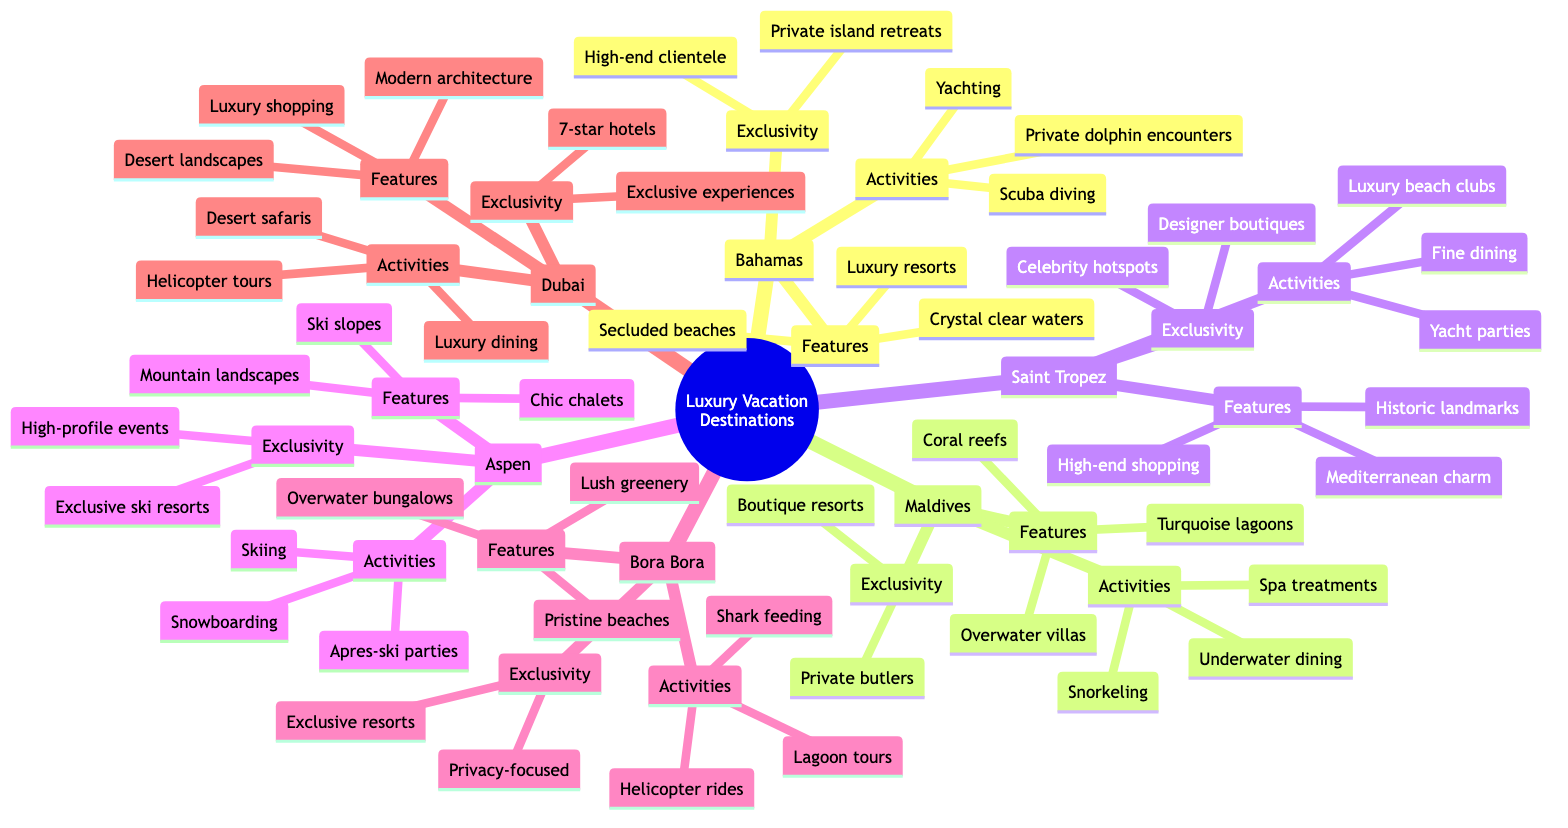What are the features of the Maldives? The diagram indicates that the Maldives has three features listed: "Overwater villas", "Turquoise lagoons", and "Coral reefs".
Answer: Overwater villas, Turquoise lagoons, Coral reefs How many luxury vacation destinations are listed in the diagram? By counting the different locations represented in the diagram, there are six destinations mentioned: Bahamas, Maldives, Saint Tropez, Aspen, Bora Bora, and Dubai.
Answer: 6 What exclusive feature is found in Bora Bora? According to the diagram, one of the exclusive features of Bora Bora is "Exclusive resorts". This information can be directly found in the Exclusive section for Bora Bora.
Answer: Exclusive resorts Which activities can you do in Aspen? The diagram details that three activities can be done in Aspen: "Skiing", "Snowboarding", and "Apres-ski parties". This information summarizes the Activities section for Aspen.
Answer: Skiing, Snowboarding, Apres-ski parties What type of dining experience is available in the Maldives? The diagram specifies that one of the activities in the Maldives is "Underwater dining", indicating a unique dining experience that combines food with an aquatic setting.
Answer: Underwater dining Which destination offers private butlers as part of its exclusivity? By examining the Exclusivity section under Maldives, it is clear that "Private butlers" are mentioned as an exclusive feature, meaning this service is offered in that location only.
Answer: Private butlers How do the features of Saint Tropez compare to those of the Bahamas? The diagram shows that Saint Tropez has "Mediterranean charm", "High-end shopping", and "Historic landmarks", while the Bahamas features "Crystal clear waters", "Secluded beaches", and "Luxury resorts". Comparing both destinations shows they focus on different aesthetic and experiential highlights.
Answer: Different aesthetic and experiential highlights What is a common activity among luxury destinations listed? Looking through the activities provided, a common luxury experience, such as "Yachting" in the Bahamas and "Yacht parties" in Saint Tropez, indicates that sailing or luxury boats are a shared activity among some of the destinations.
Answer: Yachting and similar boating activities Which destination is known for desert landscapes? The diagram indicates that the destination known for "Desert landscapes" is Dubai, as this is explicitly mentioned in the Features section for Dubai.
Answer: Dubai 